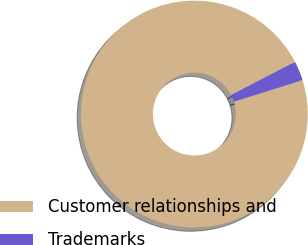Convert chart. <chart><loc_0><loc_0><loc_500><loc_500><pie_chart><fcel>Customer relationships and<fcel>Trademarks<nl><fcel>97.25%<fcel>2.75%<nl></chart> 